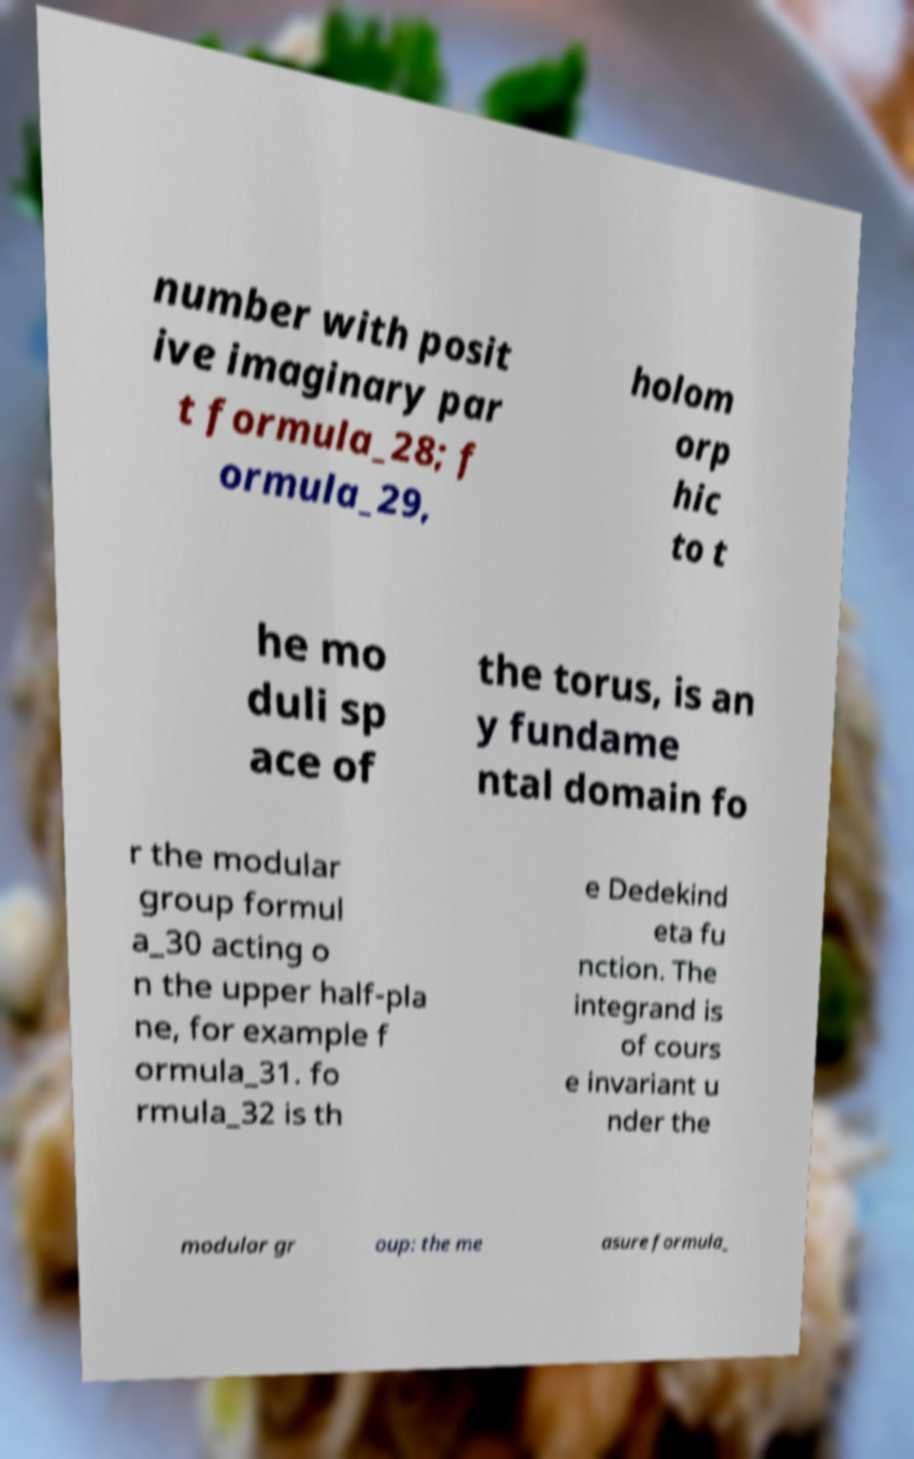Can you accurately transcribe the text from the provided image for me? number with posit ive imaginary par t formula_28; f ormula_29, holom orp hic to t he mo duli sp ace of the torus, is an y fundame ntal domain fo r the modular group formul a_30 acting o n the upper half-pla ne, for example f ormula_31. fo rmula_32 is th e Dedekind eta fu nction. The integrand is of cours e invariant u nder the modular gr oup: the me asure formula_ 